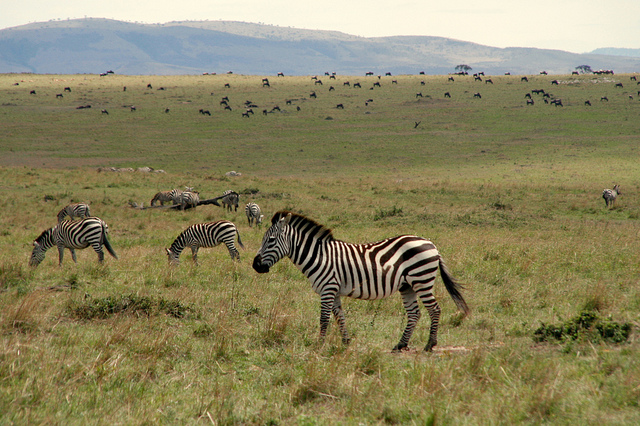<image>What is the vegetation like? It is not clear what the vegetation is like. It could be a grassy field or scrub grass. What is the vegetation like? I don't know what the vegetation is like. It can be scrub grass, grasslands, lush, or grassy. 